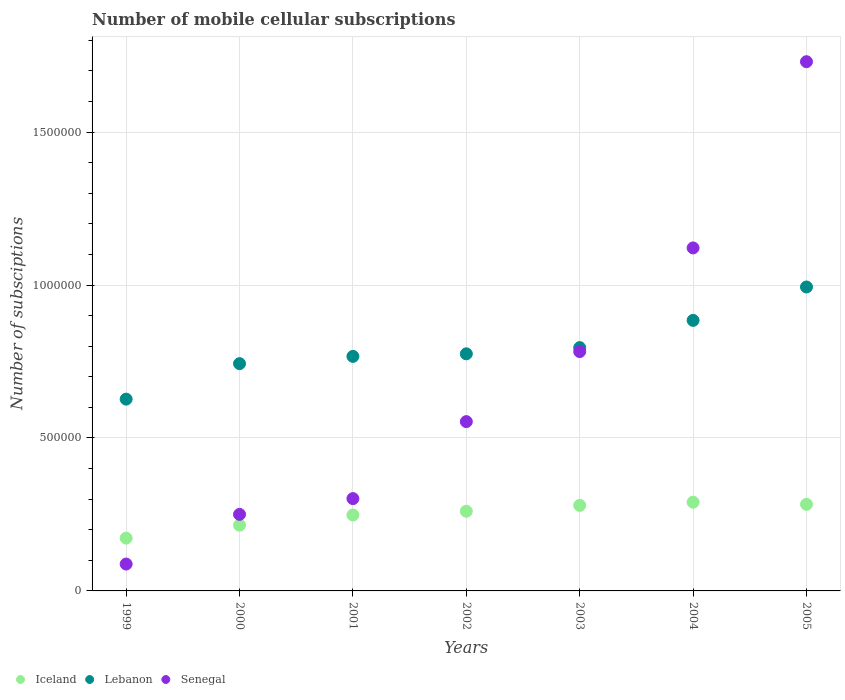How many different coloured dotlines are there?
Your answer should be compact. 3. What is the number of mobile cellular subscriptions in Lebanon in 2000?
Make the answer very short. 7.43e+05. Across all years, what is the maximum number of mobile cellular subscriptions in Lebanon?
Make the answer very short. 9.94e+05. Across all years, what is the minimum number of mobile cellular subscriptions in Senegal?
Your answer should be compact. 8.79e+04. In which year was the number of mobile cellular subscriptions in Iceland maximum?
Offer a terse response. 2004. What is the total number of mobile cellular subscriptions in Lebanon in the graph?
Make the answer very short. 5.59e+06. What is the difference between the number of mobile cellular subscriptions in Lebanon in 1999 and that in 2005?
Your response must be concise. -3.67e+05. What is the difference between the number of mobile cellular subscriptions in Senegal in 2002 and the number of mobile cellular subscriptions in Lebanon in 2000?
Your response must be concise. -1.90e+05. What is the average number of mobile cellular subscriptions in Iceland per year?
Provide a short and direct response. 2.50e+05. In the year 1999, what is the difference between the number of mobile cellular subscriptions in Iceland and number of mobile cellular subscriptions in Lebanon?
Make the answer very short. -4.54e+05. What is the ratio of the number of mobile cellular subscriptions in Lebanon in 2001 to that in 2002?
Give a very brief answer. 0.99. What is the difference between the highest and the second highest number of mobile cellular subscriptions in Lebanon?
Provide a short and direct response. 1.09e+05. What is the difference between the highest and the lowest number of mobile cellular subscriptions in Senegal?
Ensure brevity in your answer.  1.64e+06. Is it the case that in every year, the sum of the number of mobile cellular subscriptions in Lebanon and number of mobile cellular subscriptions in Iceland  is greater than the number of mobile cellular subscriptions in Senegal?
Your answer should be very brief. No. Is the number of mobile cellular subscriptions in Lebanon strictly less than the number of mobile cellular subscriptions in Iceland over the years?
Provide a short and direct response. No. How many years are there in the graph?
Make the answer very short. 7. What is the difference between two consecutive major ticks on the Y-axis?
Give a very brief answer. 5.00e+05. Are the values on the major ticks of Y-axis written in scientific E-notation?
Your answer should be compact. No. Does the graph contain any zero values?
Your answer should be very brief. No. Where does the legend appear in the graph?
Give a very brief answer. Bottom left. How many legend labels are there?
Keep it short and to the point. 3. What is the title of the graph?
Provide a succinct answer. Number of mobile cellular subscriptions. Does "Libya" appear as one of the legend labels in the graph?
Ensure brevity in your answer.  No. What is the label or title of the Y-axis?
Your answer should be very brief. Number of subsciptions. What is the Number of subsciptions of Iceland in 1999?
Ensure brevity in your answer.  1.73e+05. What is the Number of subsciptions in Lebanon in 1999?
Offer a terse response. 6.27e+05. What is the Number of subsciptions in Senegal in 1999?
Your answer should be very brief. 8.79e+04. What is the Number of subsciptions of Iceland in 2000?
Your answer should be very brief. 2.15e+05. What is the Number of subsciptions of Lebanon in 2000?
Offer a very short reply. 7.43e+05. What is the Number of subsciptions in Senegal in 2000?
Offer a terse response. 2.50e+05. What is the Number of subsciptions of Iceland in 2001?
Your answer should be compact. 2.48e+05. What is the Number of subsciptions of Lebanon in 2001?
Your response must be concise. 7.67e+05. What is the Number of subsciptions in Senegal in 2001?
Provide a short and direct response. 3.02e+05. What is the Number of subsciptions in Iceland in 2002?
Your answer should be very brief. 2.60e+05. What is the Number of subsciptions of Lebanon in 2002?
Keep it short and to the point. 7.75e+05. What is the Number of subsciptions of Senegal in 2002?
Provide a short and direct response. 5.53e+05. What is the Number of subsciptions of Iceland in 2003?
Your response must be concise. 2.80e+05. What is the Number of subsciptions of Lebanon in 2003?
Give a very brief answer. 7.95e+05. What is the Number of subsciptions of Senegal in 2003?
Ensure brevity in your answer.  7.82e+05. What is the Number of subsciptions in Iceland in 2004?
Provide a succinct answer. 2.90e+05. What is the Number of subsciptions in Lebanon in 2004?
Give a very brief answer. 8.84e+05. What is the Number of subsciptions in Senegal in 2004?
Your answer should be very brief. 1.12e+06. What is the Number of subsciptions of Iceland in 2005?
Offer a very short reply. 2.83e+05. What is the Number of subsciptions in Lebanon in 2005?
Make the answer very short. 9.94e+05. What is the Number of subsciptions in Senegal in 2005?
Offer a terse response. 1.73e+06. Across all years, what is the maximum Number of subsciptions in Iceland?
Your answer should be very brief. 2.90e+05. Across all years, what is the maximum Number of subsciptions in Lebanon?
Provide a short and direct response. 9.94e+05. Across all years, what is the maximum Number of subsciptions in Senegal?
Offer a very short reply. 1.73e+06. Across all years, what is the minimum Number of subsciptions in Iceland?
Give a very brief answer. 1.73e+05. Across all years, what is the minimum Number of subsciptions of Lebanon?
Your answer should be very brief. 6.27e+05. Across all years, what is the minimum Number of subsciptions in Senegal?
Ensure brevity in your answer.  8.79e+04. What is the total Number of subsciptions of Iceland in the graph?
Your response must be concise. 1.75e+06. What is the total Number of subsciptions in Lebanon in the graph?
Offer a terse response. 5.59e+06. What is the total Number of subsciptions of Senegal in the graph?
Give a very brief answer. 4.83e+06. What is the difference between the Number of subsciptions of Iceland in 1999 and that in 2000?
Give a very brief answer. -4.23e+04. What is the difference between the Number of subsciptions in Lebanon in 1999 and that in 2000?
Give a very brief answer. -1.16e+05. What is the difference between the Number of subsciptions in Senegal in 1999 and that in 2000?
Give a very brief answer. -1.62e+05. What is the difference between the Number of subsciptions of Iceland in 1999 and that in 2001?
Offer a very short reply. -7.55e+04. What is the difference between the Number of subsciptions of Lebanon in 1999 and that in 2001?
Keep it short and to the point. -1.40e+05. What is the difference between the Number of subsciptions of Senegal in 1999 and that in 2001?
Make the answer very short. -2.14e+05. What is the difference between the Number of subsciptions in Iceland in 1999 and that in 2002?
Make the answer very short. -8.78e+04. What is the difference between the Number of subsciptions of Lebanon in 1999 and that in 2002?
Keep it short and to the point. -1.48e+05. What is the difference between the Number of subsciptions in Senegal in 1999 and that in 2002?
Your response must be concise. -4.66e+05. What is the difference between the Number of subsciptions of Iceland in 1999 and that in 2003?
Ensure brevity in your answer.  -1.07e+05. What is the difference between the Number of subsciptions of Lebanon in 1999 and that in 2003?
Your answer should be compact. -1.68e+05. What is the difference between the Number of subsciptions in Senegal in 1999 and that in 2003?
Provide a short and direct response. -6.95e+05. What is the difference between the Number of subsciptions of Iceland in 1999 and that in 2004?
Provide a short and direct response. -1.17e+05. What is the difference between the Number of subsciptions in Lebanon in 1999 and that in 2004?
Provide a short and direct response. -2.57e+05. What is the difference between the Number of subsciptions of Senegal in 1999 and that in 2004?
Offer a very short reply. -1.03e+06. What is the difference between the Number of subsciptions in Iceland in 1999 and that in 2005?
Make the answer very short. -1.10e+05. What is the difference between the Number of subsciptions of Lebanon in 1999 and that in 2005?
Give a very brief answer. -3.67e+05. What is the difference between the Number of subsciptions of Senegal in 1999 and that in 2005?
Your response must be concise. -1.64e+06. What is the difference between the Number of subsciptions of Iceland in 2000 and that in 2001?
Give a very brief answer. -3.32e+04. What is the difference between the Number of subsciptions of Lebanon in 2000 and that in 2001?
Provide a succinct answer. -2.38e+04. What is the difference between the Number of subsciptions in Senegal in 2000 and that in 2001?
Give a very brief answer. -5.16e+04. What is the difference between the Number of subsciptions in Iceland in 2000 and that in 2002?
Give a very brief answer. -4.55e+04. What is the difference between the Number of subsciptions of Lebanon in 2000 and that in 2002?
Offer a terse response. -3.21e+04. What is the difference between the Number of subsciptions in Senegal in 2000 and that in 2002?
Offer a terse response. -3.03e+05. What is the difference between the Number of subsciptions in Iceland in 2000 and that in 2003?
Ensure brevity in your answer.  -6.48e+04. What is the difference between the Number of subsciptions in Lebanon in 2000 and that in 2003?
Give a very brief answer. -5.25e+04. What is the difference between the Number of subsciptions in Senegal in 2000 and that in 2003?
Provide a succinct answer. -5.32e+05. What is the difference between the Number of subsciptions in Iceland in 2000 and that in 2004?
Provide a succinct answer. -7.52e+04. What is the difference between the Number of subsciptions in Lebanon in 2000 and that in 2004?
Ensure brevity in your answer.  -1.41e+05. What is the difference between the Number of subsciptions in Senegal in 2000 and that in 2004?
Make the answer very short. -8.71e+05. What is the difference between the Number of subsciptions of Iceland in 2000 and that in 2005?
Provide a short and direct response. -6.82e+04. What is the difference between the Number of subsciptions of Lebanon in 2000 and that in 2005?
Give a very brief answer. -2.51e+05. What is the difference between the Number of subsciptions of Senegal in 2000 and that in 2005?
Your answer should be compact. -1.48e+06. What is the difference between the Number of subsciptions in Iceland in 2001 and that in 2002?
Give a very brief answer. -1.23e+04. What is the difference between the Number of subsciptions of Lebanon in 2001 and that in 2002?
Offer a terse response. -8350. What is the difference between the Number of subsciptions in Senegal in 2001 and that in 2002?
Keep it short and to the point. -2.52e+05. What is the difference between the Number of subsciptions in Iceland in 2001 and that in 2003?
Your response must be concise. -3.15e+04. What is the difference between the Number of subsciptions of Lebanon in 2001 and that in 2003?
Offer a very short reply. -2.87e+04. What is the difference between the Number of subsciptions in Senegal in 2001 and that in 2003?
Your response must be concise. -4.81e+05. What is the difference between the Number of subsciptions of Iceland in 2001 and that in 2004?
Your answer should be compact. -4.19e+04. What is the difference between the Number of subsciptions in Lebanon in 2001 and that in 2004?
Your answer should be very brief. -1.18e+05. What is the difference between the Number of subsciptions of Senegal in 2001 and that in 2004?
Offer a terse response. -8.20e+05. What is the difference between the Number of subsciptions in Iceland in 2001 and that in 2005?
Offer a terse response. -3.50e+04. What is the difference between the Number of subsciptions in Lebanon in 2001 and that in 2005?
Your answer should be very brief. -2.27e+05. What is the difference between the Number of subsciptions of Senegal in 2001 and that in 2005?
Give a very brief answer. -1.43e+06. What is the difference between the Number of subsciptions in Iceland in 2002 and that in 2003?
Ensure brevity in your answer.  -1.92e+04. What is the difference between the Number of subsciptions in Lebanon in 2002 and that in 2003?
Offer a terse response. -2.04e+04. What is the difference between the Number of subsciptions of Senegal in 2002 and that in 2003?
Your answer should be very brief. -2.29e+05. What is the difference between the Number of subsciptions of Iceland in 2002 and that in 2004?
Offer a terse response. -2.96e+04. What is the difference between the Number of subsciptions of Lebanon in 2002 and that in 2004?
Keep it short and to the point. -1.09e+05. What is the difference between the Number of subsciptions of Senegal in 2002 and that in 2004?
Give a very brief answer. -5.68e+05. What is the difference between the Number of subsciptions of Iceland in 2002 and that in 2005?
Offer a very short reply. -2.27e+04. What is the difference between the Number of subsciptions of Lebanon in 2002 and that in 2005?
Give a very brief answer. -2.18e+05. What is the difference between the Number of subsciptions in Senegal in 2002 and that in 2005?
Provide a succinct answer. -1.18e+06. What is the difference between the Number of subsciptions in Iceland in 2003 and that in 2004?
Make the answer very short. -1.04e+04. What is the difference between the Number of subsciptions in Lebanon in 2003 and that in 2004?
Your answer should be compact. -8.90e+04. What is the difference between the Number of subsciptions in Senegal in 2003 and that in 2004?
Offer a terse response. -3.39e+05. What is the difference between the Number of subsciptions in Iceland in 2003 and that in 2005?
Offer a very short reply. -3438. What is the difference between the Number of subsciptions of Lebanon in 2003 and that in 2005?
Ensure brevity in your answer.  -1.98e+05. What is the difference between the Number of subsciptions in Senegal in 2003 and that in 2005?
Offer a very short reply. -9.48e+05. What is the difference between the Number of subsciptions of Iceland in 2004 and that in 2005?
Give a very brief answer. 6960. What is the difference between the Number of subsciptions in Lebanon in 2004 and that in 2005?
Your answer should be very brief. -1.09e+05. What is the difference between the Number of subsciptions of Senegal in 2004 and that in 2005?
Your answer should be very brief. -6.09e+05. What is the difference between the Number of subsciptions of Iceland in 1999 and the Number of subsciptions of Lebanon in 2000?
Provide a succinct answer. -5.70e+05. What is the difference between the Number of subsciptions in Iceland in 1999 and the Number of subsciptions in Senegal in 2000?
Your response must be concise. -7.76e+04. What is the difference between the Number of subsciptions of Lebanon in 1999 and the Number of subsciptions of Senegal in 2000?
Provide a succinct answer. 3.77e+05. What is the difference between the Number of subsciptions of Iceland in 1999 and the Number of subsciptions of Lebanon in 2001?
Provide a succinct answer. -5.94e+05. What is the difference between the Number of subsciptions in Iceland in 1999 and the Number of subsciptions in Senegal in 2001?
Your response must be concise. -1.29e+05. What is the difference between the Number of subsciptions of Lebanon in 1999 and the Number of subsciptions of Senegal in 2001?
Offer a very short reply. 3.25e+05. What is the difference between the Number of subsciptions of Iceland in 1999 and the Number of subsciptions of Lebanon in 2002?
Keep it short and to the point. -6.02e+05. What is the difference between the Number of subsciptions in Iceland in 1999 and the Number of subsciptions in Senegal in 2002?
Your answer should be compact. -3.81e+05. What is the difference between the Number of subsciptions of Lebanon in 1999 and the Number of subsciptions of Senegal in 2002?
Give a very brief answer. 7.36e+04. What is the difference between the Number of subsciptions in Iceland in 1999 and the Number of subsciptions in Lebanon in 2003?
Your answer should be very brief. -6.23e+05. What is the difference between the Number of subsciptions in Iceland in 1999 and the Number of subsciptions in Senegal in 2003?
Make the answer very short. -6.10e+05. What is the difference between the Number of subsciptions in Lebanon in 1999 and the Number of subsciptions in Senegal in 2003?
Offer a very short reply. -1.55e+05. What is the difference between the Number of subsciptions in Iceland in 1999 and the Number of subsciptions in Lebanon in 2004?
Make the answer very short. -7.12e+05. What is the difference between the Number of subsciptions in Iceland in 1999 and the Number of subsciptions in Senegal in 2004?
Keep it short and to the point. -9.49e+05. What is the difference between the Number of subsciptions of Lebanon in 1999 and the Number of subsciptions of Senegal in 2004?
Offer a very short reply. -4.94e+05. What is the difference between the Number of subsciptions of Iceland in 1999 and the Number of subsciptions of Lebanon in 2005?
Provide a succinct answer. -8.21e+05. What is the difference between the Number of subsciptions in Iceland in 1999 and the Number of subsciptions in Senegal in 2005?
Your response must be concise. -1.56e+06. What is the difference between the Number of subsciptions in Lebanon in 1999 and the Number of subsciptions in Senegal in 2005?
Your answer should be compact. -1.10e+06. What is the difference between the Number of subsciptions of Iceland in 2000 and the Number of subsciptions of Lebanon in 2001?
Ensure brevity in your answer.  -5.52e+05. What is the difference between the Number of subsciptions of Iceland in 2000 and the Number of subsciptions of Senegal in 2001?
Offer a very short reply. -8.69e+04. What is the difference between the Number of subsciptions in Lebanon in 2000 and the Number of subsciptions in Senegal in 2001?
Your answer should be very brief. 4.41e+05. What is the difference between the Number of subsciptions of Iceland in 2000 and the Number of subsciptions of Lebanon in 2002?
Provide a succinct answer. -5.60e+05. What is the difference between the Number of subsciptions in Iceland in 2000 and the Number of subsciptions in Senegal in 2002?
Your response must be concise. -3.39e+05. What is the difference between the Number of subsciptions in Lebanon in 2000 and the Number of subsciptions in Senegal in 2002?
Offer a very short reply. 1.90e+05. What is the difference between the Number of subsciptions in Iceland in 2000 and the Number of subsciptions in Lebanon in 2003?
Offer a terse response. -5.81e+05. What is the difference between the Number of subsciptions of Iceland in 2000 and the Number of subsciptions of Senegal in 2003?
Ensure brevity in your answer.  -5.68e+05. What is the difference between the Number of subsciptions of Lebanon in 2000 and the Number of subsciptions of Senegal in 2003?
Your answer should be compact. -3.94e+04. What is the difference between the Number of subsciptions of Iceland in 2000 and the Number of subsciptions of Lebanon in 2004?
Your response must be concise. -6.70e+05. What is the difference between the Number of subsciptions of Iceland in 2000 and the Number of subsciptions of Senegal in 2004?
Give a very brief answer. -9.06e+05. What is the difference between the Number of subsciptions in Lebanon in 2000 and the Number of subsciptions in Senegal in 2004?
Keep it short and to the point. -3.78e+05. What is the difference between the Number of subsciptions of Iceland in 2000 and the Number of subsciptions of Lebanon in 2005?
Your answer should be very brief. -7.79e+05. What is the difference between the Number of subsciptions in Iceland in 2000 and the Number of subsciptions in Senegal in 2005?
Your answer should be compact. -1.52e+06. What is the difference between the Number of subsciptions of Lebanon in 2000 and the Number of subsciptions of Senegal in 2005?
Your answer should be compact. -9.87e+05. What is the difference between the Number of subsciptions of Iceland in 2001 and the Number of subsciptions of Lebanon in 2002?
Your answer should be compact. -5.27e+05. What is the difference between the Number of subsciptions of Iceland in 2001 and the Number of subsciptions of Senegal in 2002?
Provide a short and direct response. -3.05e+05. What is the difference between the Number of subsciptions in Lebanon in 2001 and the Number of subsciptions in Senegal in 2002?
Ensure brevity in your answer.  2.13e+05. What is the difference between the Number of subsciptions of Iceland in 2001 and the Number of subsciptions of Lebanon in 2003?
Make the answer very short. -5.47e+05. What is the difference between the Number of subsciptions in Iceland in 2001 and the Number of subsciptions in Senegal in 2003?
Your answer should be compact. -5.34e+05. What is the difference between the Number of subsciptions in Lebanon in 2001 and the Number of subsciptions in Senegal in 2003?
Provide a short and direct response. -1.57e+04. What is the difference between the Number of subsciptions in Iceland in 2001 and the Number of subsciptions in Lebanon in 2004?
Provide a succinct answer. -6.36e+05. What is the difference between the Number of subsciptions in Iceland in 2001 and the Number of subsciptions in Senegal in 2004?
Your response must be concise. -8.73e+05. What is the difference between the Number of subsciptions of Lebanon in 2001 and the Number of subsciptions of Senegal in 2004?
Keep it short and to the point. -3.55e+05. What is the difference between the Number of subsciptions of Iceland in 2001 and the Number of subsciptions of Lebanon in 2005?
Ensure brevity in your answer.  -7.45e+05. What is the difference between the Number of subsciptions of Iceland in 2001 and the Number of subsciptions of Senegal in 2005?
Your answer should be compact. -1.48e+06. What is the difference between the Number of subsciptions in Lebanon in 2001 and the Number of subsciptions in Senegal in 2005?
Offer a very short reply. -9.63e+05. What is the difference between the Number of subsciptions in Iceland in 2002 and the Number of subsciptions in Lebanon in 2003?
Keep it short and to the point. -5.35e+05. What is the difference between the Number of subsciptions in Iceland in 2002 and the Number of subsciptions in Senegal in 2003?
Ensure brevity in your answer.  -5.22e+05. What is the difference between the Number of subsciptions in Lebanon in 2002 and the Number of subsciptions in Senegal in 2003?
Make the answer very short. -7319. What is the difference between the Number of subsciptions of Iceland in 2002 and the Number of subsciptions of Lebanon in 2004?
Give a very brief answer. -6.24e+05. What is the difference between the Number of subsciptions of Iceland in 2002 and the Number of subsciptions of Senegal in 2004?
Give a very brief answer. -8.61e+05. What is the difference between the Number of subsciptions in Lebanon in 2002 and the Number of subsciptions in Senegal in 2004?
Offer a very short reply. -3.46e+05. What is the difference between the Number of subsciptions in Iceland in 2002 and the Number of subsciptions in Lebanon in 2005?
Your answer should be compact. -7.33e+05. What is the difference between the Number of subsciptions in Iceland in 2002 and the Number of subsciptions in Senegal in 2005?
Keep it short and to the point. -1.47e+06. What is the difference between the Number of subsciptions of Lebanon in 2002 and the Number of subsciptions of Senegal in 2005?
Ensure brevity in your answer.  -9.55e+05. What is the difference between the Number of subsciptions in Iceland in 2003 and the Number of subsciptions in Lebanon in 2004?
Provide a short and direct response. -6.05e+05. What is the difference between the Number of subsciptions of Iceland in 2003 and the Number of subsciptions of Senegal in 2004?
Make the answer very short. -8.42e+05. What is the difference between the Number of subsciptions of Lebanon in 2003 and the Number of subsciptions of Senegal in 2004?
Ensure brevity in your answer.  -3.26e+05. What is the difference between the Number of subsciptions in Iceland in 2003 and the Number of subsciptions in Lebanon in 2005?
Your answer should be very brief. -7.14e+05. What is the difference between the Number of subsciptions in Iceland in 2003 and the Number of subsciptions in Senegal in 2005?
Give a very brief answer. -1.45e+06. What is the difference between the Number of subsciptions of Lebanon in 2003 and the Number of subsciptions of Senegal in 2005?
Your response must be concise. -9.35e+05. What is the difference between the Number of subsciptions in Iceland in 2004 and the Number of subsciptions in Lebanon in 2005?
Ensure brevity in your answer.  -7.03e+05. What is the difference between the Number of subsciptions in Iceland in 2004 and the Number of subsciptions in Senegal in 2005?
Keep it short and to the point. -1.44e+06. What is the difference between the Number of subsciptions of Lebanon in 2004 and the Number of subsciptions of Senegal in 2005?
Your response must be concise. -8.46e+05. What is the average Number of subsciptions in Iceland per year?
Offer a terse response. 2.50e+05. What is the average Number of subsciptions in Lebanon per year?
Offer a terse response. 7.98e+05. What is the average Number of subsciptions in Senegal per year?
Your answer should be very brief. 6.90e+05. In the year 1999, what is the difference between the Number of subsciptions of Iceland and Number of subsciptions of Lebanon?
Your answer should be very brief. -4.54e+05. In the year 1999, what is the difference between the Number of subsciptions in Iceland and Number of subsciptions in Senegal?
Keep it short and to the point. 8.47e+04. In the year 1999, what is the difference between the Number of subsciptions of Lebanon and Number of subsciptions of Senegal?
Provide a succinct answer. 5.39e+05. In the year 2000, what is the difference between the Number of subsciptions of Iceland and Number of subsciptions of Lebanon?
Provide a short and direct response. -5.28e+05. In the year 2000, what is the difference between the Number of subsciptions of Iceland and Number of subsciptions of Senegal?
Offer a terse response. -3.54e+04. In the year 2000, what is the difference between the Number of subsciptions in Lebanon and Number of subsciptions in Senegal?
Provide a short and direct response. 4.93e+05. In the year 2001, what is the difference between the Number of subsciptions in Iceland and Number of subsciptions in Lebanon?
Give a very brief answer. -5.19e+05. In the year 2001, what is the difference between the Number of subsciptions in Iceland and Number of subsciptions in Senegal?
Provide a succinct answer. -5.37e+04. In the year 2001, what is the difference between the Number of subsciptions of Lebanon and Number of subsciptions of Senegal?
Your response must be concise. 4.65e+05. In the year 2002, what is the difference between the Number of subsciptions in Iceland and Number of subsciptions in Lebanon?
Ensure brevity in your answer.  -5.15e+05. In the year 2002, what is the difference between the Number of subsciptions of Iceland and Number of subsciptions of Senegal?
Give a very brief answer. -2.93e+05. In the year 2002, what is the difference between the Number of subsciptions in Lebanon and Number of subsciptions in Senegal?
Make the answer very short. 2.22e+05. In the year 2003, what is the difference between the Number of subsciptions in Iceland and Number of subsciptions in Lebanon?
Provide a succinct answer. -5.16e+05. In the year 2003, what is the difference between the Number of subsciptions in Iceland and Number of subsciptions in Senegal?
Your response must be concise. -5.03e+05. In the year 2003, what is the difference between the Number of subsciptions of Lebanon and Number of subsciptions of Senegal?
Provide a short and direct response. 1.30e+04. In the year 2004, what is the difference between the Number of subsciptions in Iceland and Number of subsciptions in Lebanon?
Make the answer very short. -5.94e+05. In the year 2004, what is the difference between the Number of subsciptions in Iceland and Number of subsciptions in Senegal?
Your response must be concise. -8.31e+05. In the year 2004, what is the difference between the Number of subsciptions in Lebanon and Number of subsciptions in Senegal?
Offer a very short reply. -2.37e+05. In the year 2005, what is the difference between the Number of subsciptions in Iceland and Number of subsciptions in Lebanon?
Offer a very short reply. -7.10e+05. In the year 2005, what is the difference between the Number of subsciptions in Iceland and Number of subsciptions in Senegal?
Your response must be concise. -1.45e+06. In the year 2005, what is the difference between the Number of subsciptions in Lebanon and Number of subsciptions in Senegal?
Provide a short and direct response. -7.37e+05. What is the ratio of the Number of subsciptions of Iceland in 1999 to that in 2000?
Your answer should be compact. 0.8. What is the ratio of the Number of subsciptions of Lebanon in 1999 to that in 2000?
Keep it short and to the point. 0.84. What is the ratio of the Number of subsciptions of Senegal in 1999 to that in 2000?
Your answer should be compact. 0.35. What is the ratio of the Number of subsciptions in Iceland in 1999 to that in 2001?
Keep it short and to the point. 0.7. What is the ratio of the Number of subsciptions of Lebanon in 1999 to that in 2001?
Give a very brief answer. 0.82. What is the ratio of the Number of subsciptions of Senegal in 1999 to that in 2001?
Your response must be concise. 0.29. What is the ratio of the Number of subsciptions in Iceland in 1999 to that in 2002?
Offer a terse response. 0.66. What is the ratio of the Number of subsciptions in Lebanon in 1999 to that in 2002?
Your answer should be very brief. 0.81. What is the ratio of the Number of subsciptions in Senegal in 1999 to that in 2002?
Make the answer very short. 0.16. What is the ratio of the Number of subsciptions in Iceland in 1999 to that in 2003?
Your answer should be compact. 0.62. What is the ratio of the Number of subsciptions of Lebanon in 1999 to that in 2003?
Your answer should be compact. 0.79. What is the ratio of the Number of subsciptions in Senegal in 1999 to that in 2003?
Your response must be concise. 0.11. What is the ratio of the Number of subsciptions of Iceland in 1999 to that in 2004?
Your response must be concise. 0.6. What is the ratio of the Number of subsciptions in Lebanon in 1999 to that in 2004?
Provide a succinct answer. 0.71. What is the ratio of the Number of subsciptions of Senegal in 1999 to that in 2004?
Your answer should be compact. 0.08. What is the ratio of the Number of subsciptions in Iceland in 1999 to that in 2005?
Offer a terse response. 0.61. What is the ratio of the Number of subsciptions of Lebanon in 1999 to that in 2005?
Offer a very short reply. 0.63. What is the ratio of the Number of subsciptions in Senegal in 1999 to that in 2005?
Give a very brief answer. 0.05. What is the ratio of the Number of subsciptions in Iceland in 2000 to that in 2001?
Provide a short and direct response. 0.87. What is the ratio of the Number of subsciptions of Lebanon in 2000 to that in 2001?
Your response must be concise. 0.97. What is the ratio of the Number of subsciptions in Senegal in 2000 to that in 2001?
Your answer should be compact. 0.83. What is the ratio of the Number of subsciptions of Iceland in 2000 to that in 2002?
Your answer should be very brief. 0.83. What is the ratio of the Number of subsciptions of Lebanon in 2000 to that in 2002?
Offer a terse response. 0.96. What is the ratio of the Number of subsciptions in Senegal in 2000 to that in 2002?
Offer a very short reply. 0.45. What is the ratio of the Number of subsciptions of Iceland in 2000 to that in 2003?
Offer a very short reply. 0.77. What is the ratio of the Number of subsciptions of Lebanon in 2000 to that in 2003?
Keep it short and to the point. 0.93. What is the ratio of the Number of subsciptions in Senegal in 2000 to that in 2003?
Keep it short and to the point. 0.32. What is the ratio of the Number of subsciptions in Iceland in 2000 to that in 2004?
Give a very brief answer. 0.74. What is the ratio of the Number of subsciptions in Lebanon in 2000 to that in 2004?
Provide a succinct answer. 0.84. What is the ratio of the Number of subsciptions in Senegal in 2000 to that in 2004?
Provide a succinct answer. 0.22. What is the ratio of the Number of subsciptions of Iceland in 2000 to that in 2005?
Provide a succinct answer. 0.76. What is the ratio of the Number of subsciptions of Lebanon in 2000 to that in 2005?
Ensure brevity in your answer.  0.75. What is the ratio of the Number of subsciptions in Senegal in 2000 to that in 2005?
Give a very brief answer. 0.14. What is the ratio of the Number of subsciptions of Iceland in 2001 to that in 2002?
Provide a succinct answer. 0.95. What is the ratio of the Number of subsciptions in Lebanon in 2001 to that in 2002?
Provide a succinct answer. 0.99. What is the ratio of the Number of subsciptions of Senegal in 2001 to that in 2002?
Your response must be concise. 0.55. What is the ratio of the Number of subsciptions in Iceland in 2001 to that in 2003?
Your answer should be compact. 0.89. What is the ratio of the Number of subsciptions in Lebanon in 2001 to that in 2003?
Provide a short and direct response. 0.96. What is the ratio of the Number of subsciptions of Senegal in 2001 to that in 2003?
Keep it short and to the point. 0.39. What is the ratio of the Number of subsciptions in Iceland in 2001 to that in 2004?
Keep it short and to the point. 0.86. What is the ratio of the Number of subsciptions of Lebanon in 2001 to that in 2004?
Give a very brief answer. 0.87. What is the ratio of the Number of subsciptions of Senegal in 2001 to that in 2004?
Offer a terse response. 0.27. What is the ratio of the Number of subsciptions in Iceland in 2001 to that in 2005?
Provide a short and direct response. 0.88. What is the ratio of the Number of subsciptions of Lebanon in 2001 to that in 2005?
Offer a terse response. 0.77. What is the ratio of the Number of subsciptions of Senegal in 2001 to that in 2005?
Offer a terse response. 0.17. What is the ratio of the Number of subsciptions of Iceland in 2002 to that in 2003?
Ensure brevity in your answer.  0.93. What is the ratio of the Number of subsciptions in Lebanon in 2002 to that in 2003?
Provide a short and direct response. 0.97. What is the ratio of the Number of subsciptions of Senegal in 2002 to that in 2003?
Your answer should be very brief. 0.71. What is the ratio of the Number of subsciptions of Iceland in 2002 to that in 2004?
Offer a terse response. 0.9. What is the ratio of the Number of subsciptions in Lebanon in 2002 to that in 2004?
Give a very brief answer. 0.88. What is the ratio of the Number of subsciptions in Senegal in 2002 to that in 2004?
Give a very brief answer. 0.49. What is the ratio of the Number of subsciptions in Iceland in 2002 to that in 2005?
Ensure brevity in your answer.  0.92. What is the ratio of the Number of subsciptions of Lebanon in 2002 to that in 2005?
Your answer should be compact. 0.78. What is the ratio of the Number of subsciptions in Senegal in 2002 to that in 2005?
Offer a very short reply. 0.32. What is the ratio of the Number of subsciptions of Iceland in 2003 to that in 2004?
Your answer should be compact. 0.96. What is the ratio of the Number of subsciptions of Lebanon in 2003 to that in 2004?
Offer a very short reply. 0.9. What is the ratio of the Number of subsciptions in Senegal in 2003 to that in 2004?
Provide a succinct answer. 0.7. What is the ratio of the Number of subsciptions of Iceland in 2003 to that in 2005?
Ensure brevity in your answer.  0.99. What is the ratio of the Number of subsciptions of Lebanon in 2003 to that in 2005?
Your answer should be very brief. 0.8. What is the ratio of the Number of subsciptions of Senegal in 2003 to that in 2005?
Ensure brevity in your answer.  0.45. What is the ratio of the Number of subsciptions of Iceland in 2004 to that in 2005?
Your answer should be very brief. 1.02. What is the ratio of the Number of subsciptions in Lebanon in 2004 to that in 2005?
Keep it short and to the point. 0.89. What is the ratio of the Number of subsciptions in Senegal in 2004 to that in 2005?
Offer a very short reply. 0.65. What is the difference between the highest and the second highest Number of subsciptions in Iceland?
Make the answer very short. 6960. What is the difference between the highest and the second highest Number of subsciptions of Lebanon?
Your response must be concise. 1.09e+05. What is the difference between the highest and the second highest Number of subsciptions in Senegal?
Make the answer very short. 6.09e+05. What is the difference between the highest and the lowest Number of subsciptions of Iceland?
Your answer should be very brief. 1.17e+05. What is the difference between the highest and the lowest Number of subsciptions of Lebanon?
Your answer should be very brief. 3.67e+05. What is the difference between the highest and the lowest Number of subsciptions in Senegal?
Your response must be concise. 1.64e+06. 